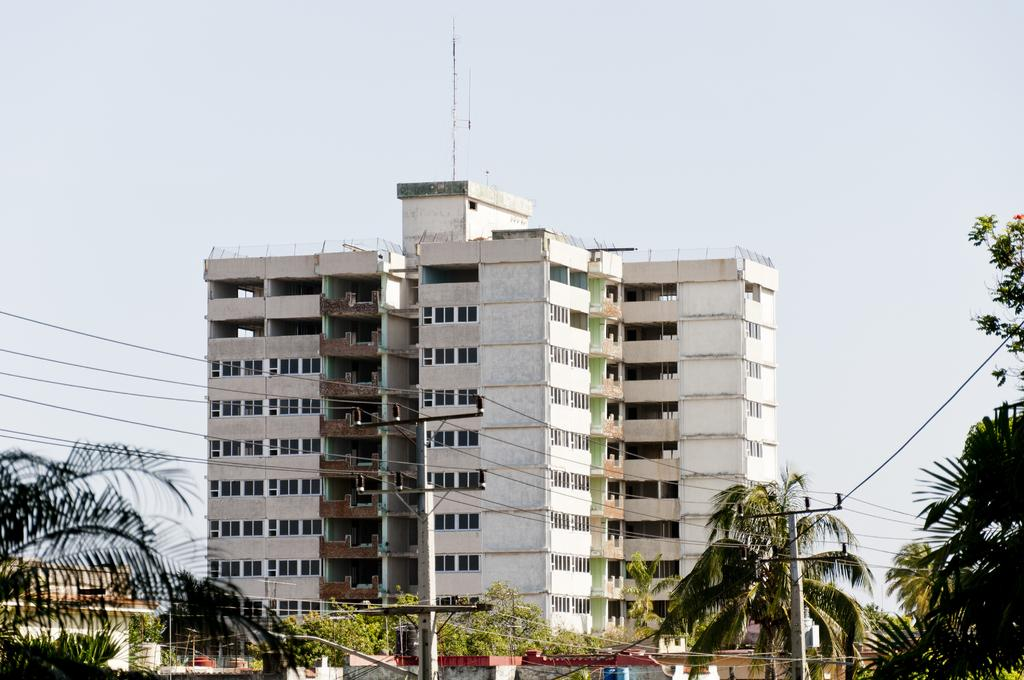What type of structures can be seen in the image? There are buildings in the image. What other natural elements are present in the image? There are trees in the image. Are there any man-made structures related to electricity in the image? Yes, there are current poles and wires in the image. What can be seen in the background of the image? The sky is visible in the background of the image. What color is the crayon used to draw the buildings in the image? There is no crayon present in the image; the buildings are depicted in a realistic manner. 